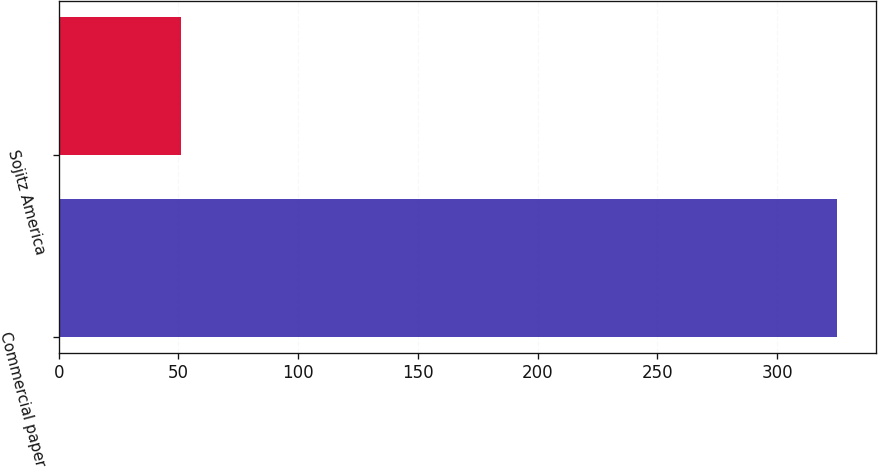<chart> <loc_0><loc_0><loc_500><loc_500><bar_chart><fcel>Commercial paper<fcel>Sojitz America<nl><fcel>325<fcel>51<nl></chart> 